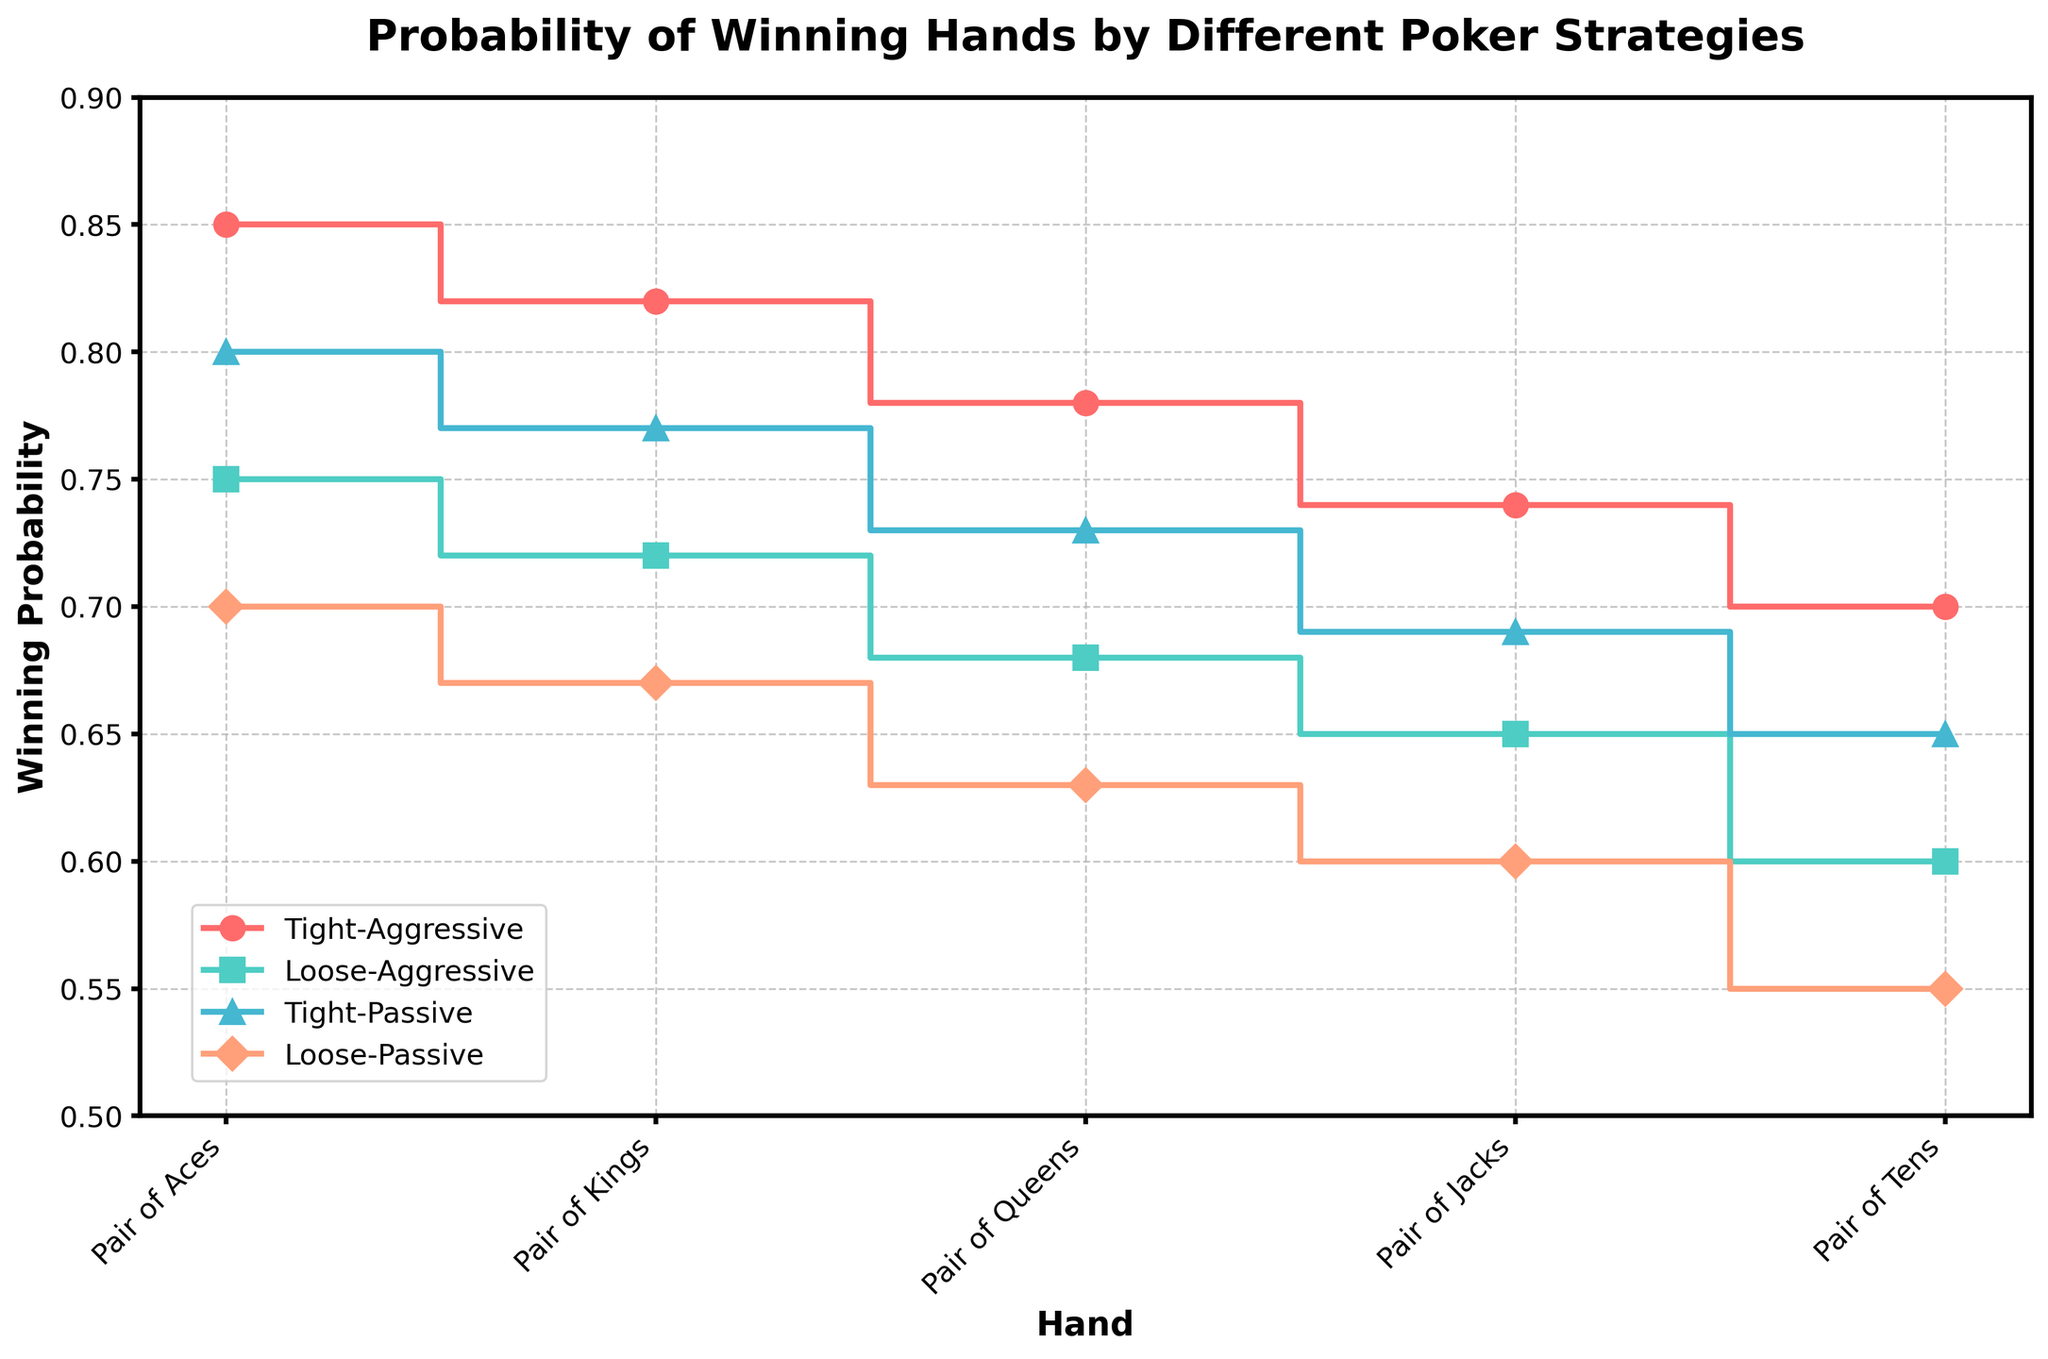What's the title of the plot? The title of the plot is usually displayed at the top and is meant to provide a summary of what the plot represents. Here, it says, "Probability of Winning Hands by Different Poker Strategies."
Answer: Probability of Winning Hands by Different Poker Strategies Which strategy has the highest probability of winning with a Pair of Aces? To determine this, you look at the y-axis values corresponding to the Pair of Aces on the x-axis across all strategies. The one with the highest y-value is Tight-Aggressive.
Answer: Tight-Aggressive How does the winning probability of Loose-Aggressive with a Pair of Kings compare to Tight-Passive with a Pair of Queens? Compare the y-axis values for Loose-Aggressive with a Pair of Kings and Tight-Passive with a Pair of Queens. Loose-Aggressive with a Pair of Kings has a probability of 0.72, while Tight-Passive with a Pair of Queens has 0.73. Hence, Tight-Passive with a Pair of Queens has a slightly higher probability.
Answer: Tight-Passive with a Pair of Queens is higher Which strategy shows a 0.65 probability of winning with a Pair of Jacks? Look at the y-axis value of 0.65 on the winning probability scale and find which strategy corresponds to this value for a Pair of Jacks on the x-axis. This value corresponds to Loose-Aggressive.
Answer: Loose-Aggressive What's the difference in winning probability between Tight-Aggressive and Loose-Passive with a Pair of Tens? From the plot, Tight-Aggressive with a Pair of Tens shows a winning probability of 0.70, and Loose-Passive shows 0.55. The difference is 0.70 - 0.55 = 0.15.
Answer: 0.15 Which strategies have winning probabilities below 0.65 with a Pair of Queens? Find the strategies where the y-values are below 0.65 for the Pair of Queens on the x-axis. Loose-Aggressive and Loose-Passive have winning probabilities below 0.65 with a Pair of Queens.
Answer: Loose-Aggressive, Loose-Passive What is the range of winning probabilities for Tight-Passive across all hands shown? Look at the highest and lowest y-values (winning probabilities) for Tight-Passive across all x-axis values. The highest is 0.80 (Pair of Aces), and the lowest is 0.65 (Pair of Tens). The range is 0.80 - 0.65 = 0.15.
Answer: 0.15 Are there any strategies that overlap in winning probability for Pair of Jacks? Examine the y-values for Pair of Jacks (x-axis) across all strategies. Both Tight-Passive and Loose-Aggressive share the same winning probability of 0.65.
Answer: Yes, Tight-Passive and Loose-Aggressive Which poker strategy consistently shows the highest probability of winning across all hands? Look for the strategy with the highest y-values (winning probabilities) for each hand on the x-axis. Tight-Aggressive strategy consistently shows the highest probability across all hands.
Answer: Tight-Aggressive 